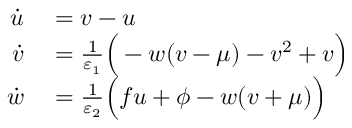<formula> <loc_0><loc_0><loc_500><loc_500>\begin{array} { r l } { \dot { u } } & = v - u } \\ { \dot { v } } & = \frac { 1 } { \varepsilon _ { 1 } } \left ( - w ( v - \mu ) - v ^ { 2 } + v \right ) } \\ { \dot { w } } & = \frac { 1 } { \varepsilon _ { 2 } } \left ( f u + \phi - w ( v + \mu ) \right ) } \end{array}</formula> 